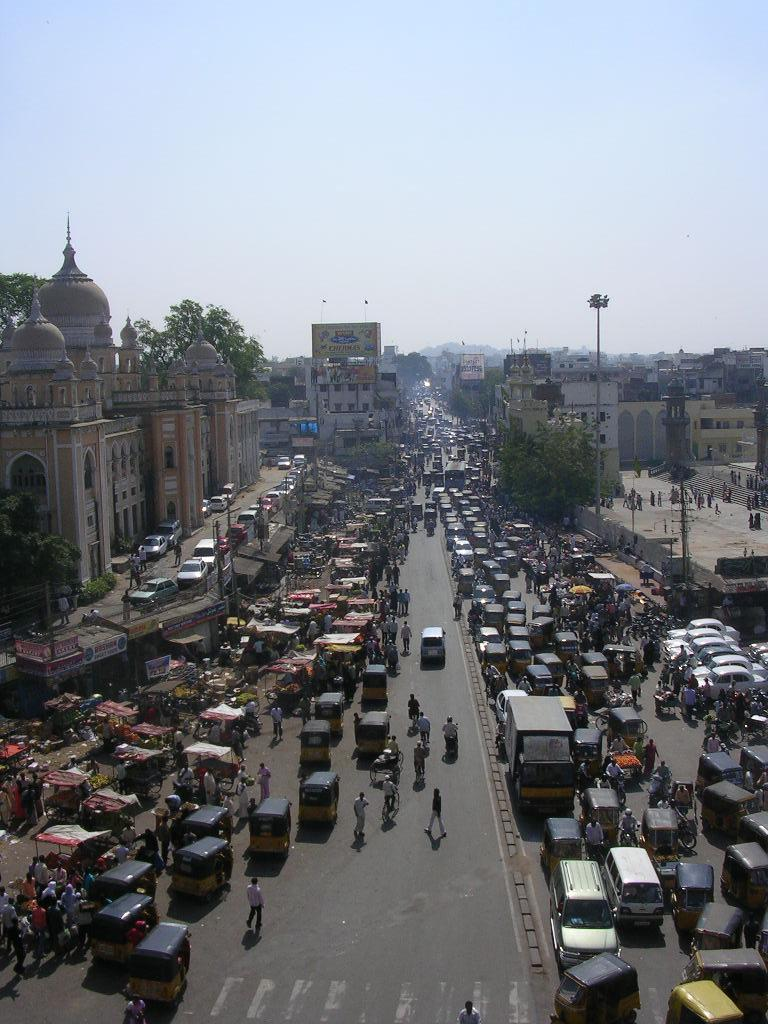What is the main feature of the image? There is a road in the image. What is happening on the road? Vehicles are moving on the road. What else can be seen in the image besides the road? There are buildings and trees visible in the image. What is visible in the background of the image? The sky is visible in the background of the image. What type of behavior can be observed in the ocean in the image? There is no ocean present in the image; it features a road with vehicles and buildings. 